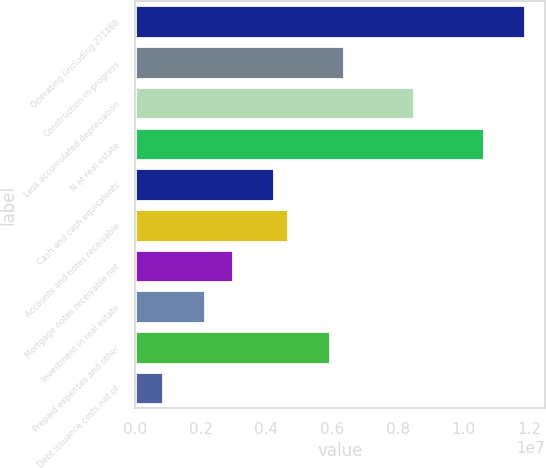<chart> <loc_0><loc_0><loc_500><loc_500><bar_chart><fcel>Operating (including 271468<fcel>Construction-in-progress<fcel>Less accumulated depreciation<fcel>N et real estate<fcel>Cash and cash equivalents<fcel>Accounts and notes receivable<fcel>Mortgage notes receivable net<fcel>Investment in real estate<fcel>Prepaid expenses and other<fcel>Debt issuance costs net of<nl><fcel>1.18728e+07<fcel>6.36074e+06<fcel>8.48078e+06<fcel>1.06008e+07<fcel>4.24071e+06<fcel>4.66472e+06<fcel>2.96869e+06<fcel>2.12067e+06<fcel>5.93674e+06<fcel>848650<nl></chart> 